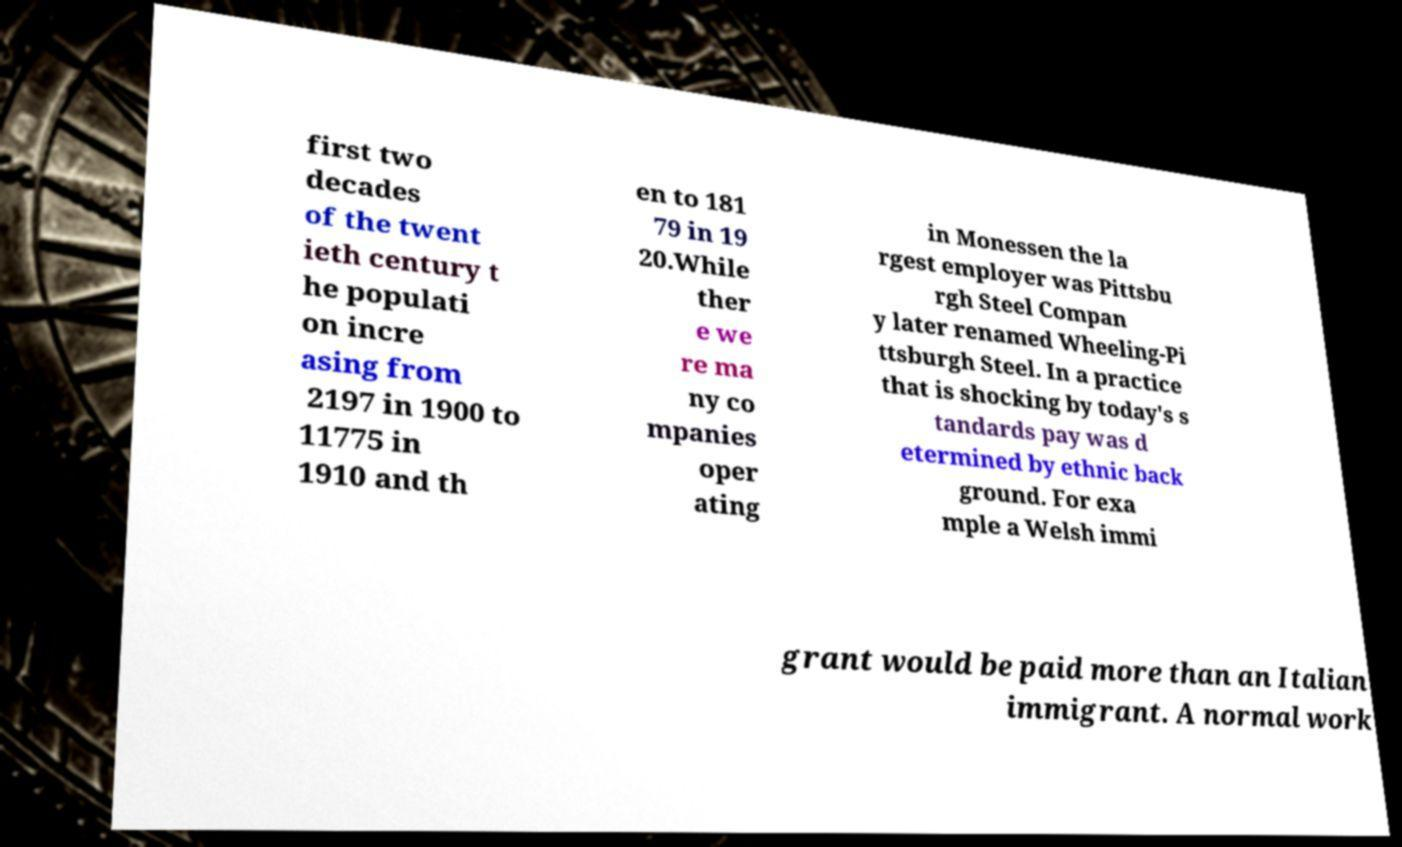I need the written content from this picture converted into text. Can you do that? first two decades of the twent ieth century t he populati on incre asing from 2197 in 1900 to 11775 in 1910 and th en to 181 79 in 19 20.While ther e we re ma ny co mpanies oper ating in Monessen the la rgest employer was Pittsbu rgh Steel Compan y later renamed Wheeling-Pi ttsburgh Steel. In a practice that is shocking by today's s tandards pay was d etermined by ethnic back ground. For exa mple a Welsh immi grant would be paid more than an Italian immigrant. A normal work 